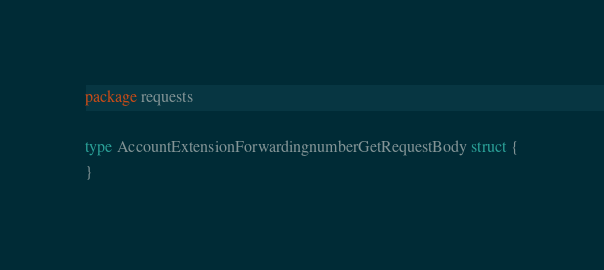<code> <loc_0><loc_0><loc_500><loc_500><_Go_>package requests

type AccountExtensionForwardingnumberGetRequestBody struct {
}
</code> 